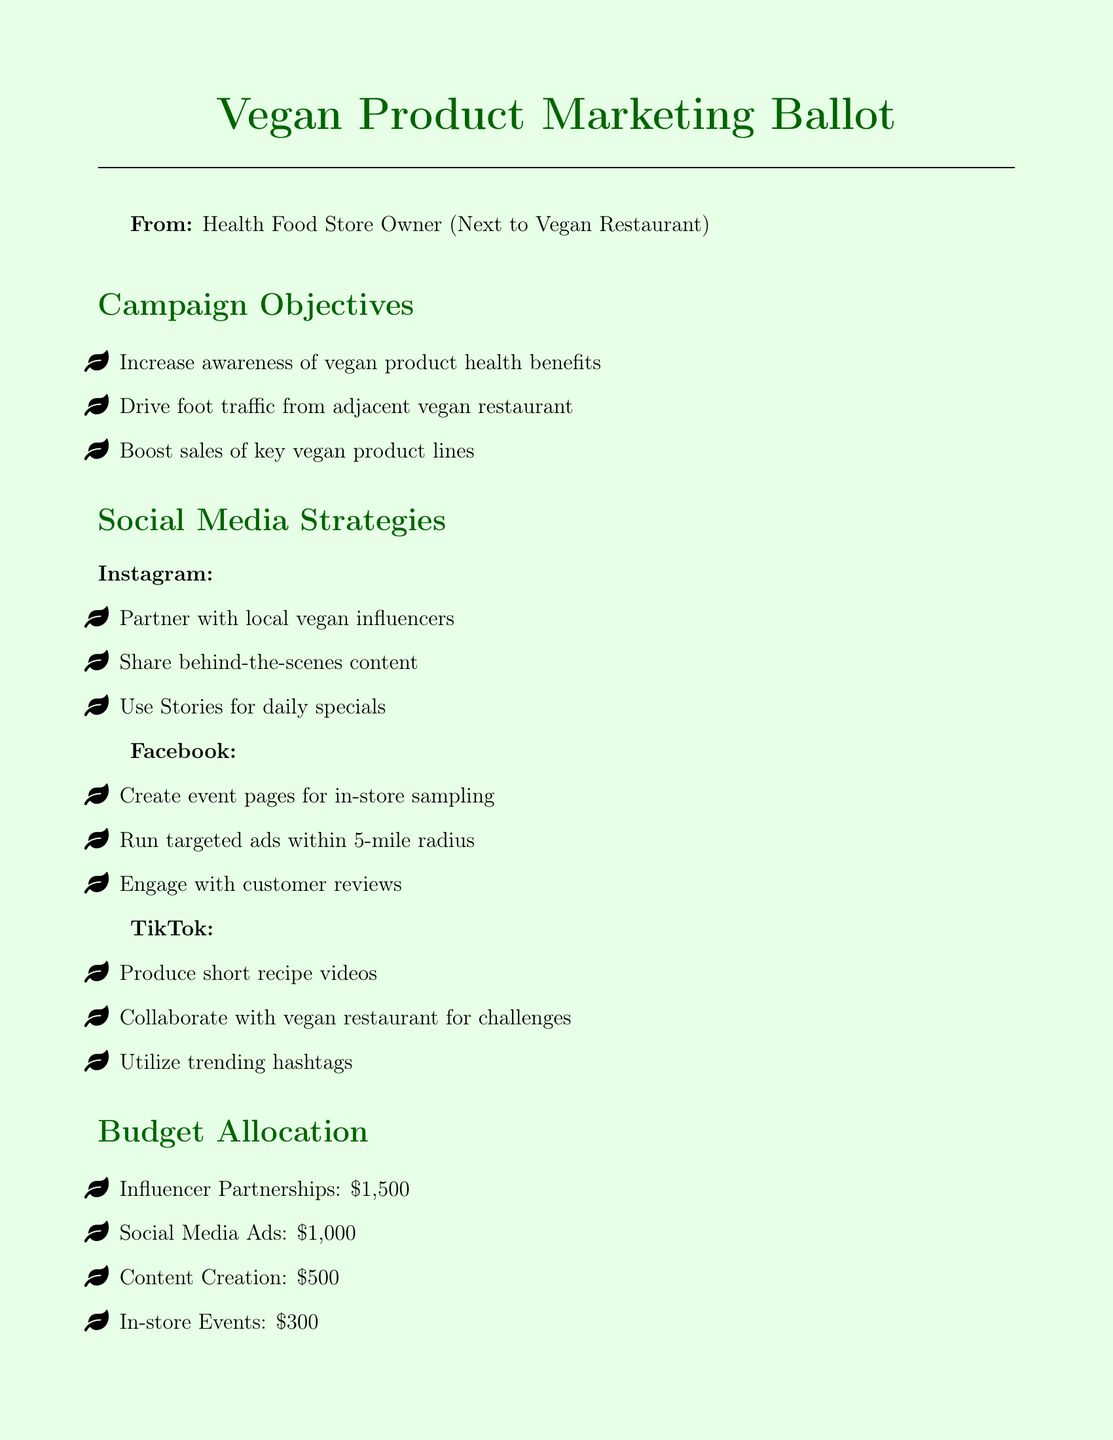What is the total budget allocation for influencer partnerships? The total budget amount for influencer partnerships listed in the document is specified explicitly.
Answer: $1,500 What social media platform focuses on recipe videos? The document highlights the platform that emphasizes short recipe videos as part of its strategy.
Answer: TikTok How many campaign objectives are listed? The total number of campaign objectives in the document can be determined by counting them in the respective section.
Answer: 3 What is one of the key metrics to monitor? The document outlines several metrics, one of which can be directly referenced.
Answer: Social media reach and engagement rates What type of events are planned for Facebook? The document specifies the kind of events that will be created on Facebook specifically related to in-store activities.
Answer: In-store sampling Which social media strategy involves local influencers? The document mentions a specific strategy that entails collaboration with local influencers, which can be identified by the platform mentioned.
Answer: Instagram 